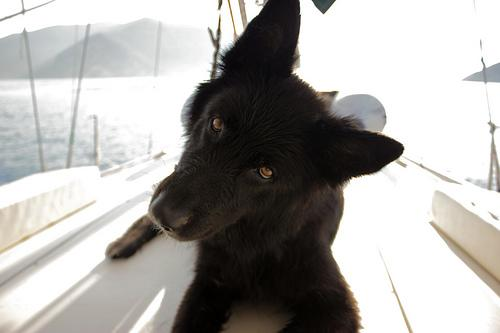Using the given captions, count the total number of objects in the image. There are six objects: dog, dog's head, water, mountains, boat, and a small, skinny pole. Explain the scene in the image involving a dog and what it is doing. A black dog is laying down with its head tilted to the side, showing its large ears, orange eyes, and black snout. Is there any specific detail about the dog's eyes that stands out in the image? The dog's eyes are small, round, and have a distinctive orange color. Assess the overall sentiment of the image based on the given information. The sentiment of the image is calm and peaceful, with a black dog laying down near the calm water and mountains in the distance. Mention the objects seen on the water and give a description of their appearance. A white metallic boat is seen on the water with shadows on the floor of the boat. Enumerate the visible parts of the dog's face and body, and describe their appearance in detail. The dog's left and right ears are large, left and right eyes are small and round with hazel color, nose is black, fur is black, and legs are visible with one paw sticking out. Analyze the interaction between the dog and the environment in the image. The dog seems to be enjoying the calm, peaceful environment near the water and mountains, with its head tilted to the_side, eyes gazing, and one paw sticking out. Compose a sentence that describes the lighting and environment of the scene. Light is gently shining on the calm water, creating a tranquil atmosphere with mountains in the background. Create an imaginative narrative of the scene with the dog and the boat. A curious dog gazes upon a white metallic boat floating on the serene blue water, with sparkling light reflecting upon the surface. Majestic mountains loom in the distance, casting shadows onto the boat's floor. Look for the cat with a purple collar on the left side. Can you spot it? No, it's not mentioned in the image. What kind of body part is sticking out near the bottom left of the image? Paw In the image, can you spot any distinct characteristics regarding the dog's fur? Tuft of black hair What is the primary color of the dog's fur? Black What is the color of the boat? White What type of boat is visible in the image? a) rowboat What color are the dog's eyes? Hazel What is the material of the boat? Metallic Describe the scene in the image with a focus on the dog's position and the surrounding environment. Black dog laying down with its head tilted to the side near a boat on calm blue water, mountains in the background Based on the water's appearance, can you determine its condition? Calm Describe the dog's pose in the image. Laying down with its head tilted to the side Which one describes the dog's ears best: floppy, pointed, big or small? Big Notice how the dog is playing with a red ball? This instruction is misleading because there is no mention of the dog playing with a ball or any object, let alone a red one. The declarative sentence suggests the existence of a red ball in the image, which is not supported by the given information. Identify the position and appearance of the dog's eye with the most specific description. Small round hazel eye, slightly higher than the middle part of the image In the image, there is an object related to the dog's feet. Describe it. Paw sticking out How can you describe the physical appearance of both of the dog's legs? Left leg is thin, while the right leg is thicker Can you spot any unique features on the dog's face? Black snout and orange eyes Identify the color and shape of the dog's eye that is most visible. Orange, round What is the emotion displayed by the dog? Neutral or content 